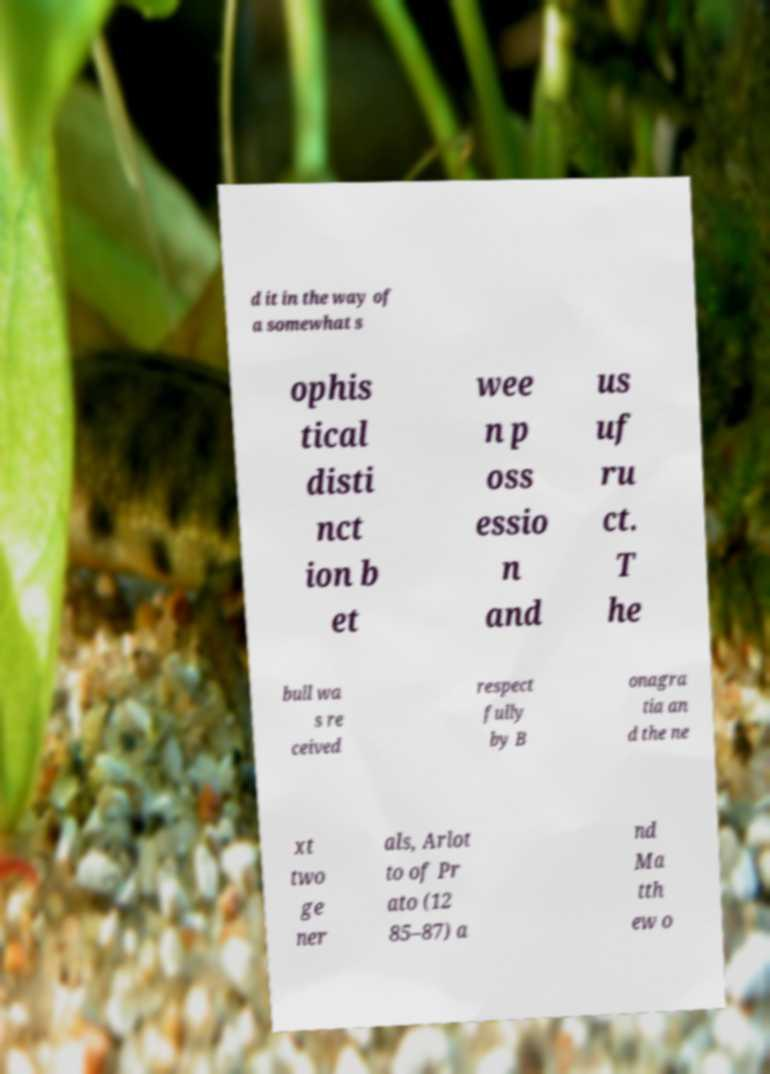Please read and relay the text visible in this image. What does it say? d it in the way of a somewhat s ophis tical disti nct ion b et wee n p oss essio n and us uf ru ct. T he bull wa s re ceived respect fully by B onagra tia an d the ne xt two ge ner als, Arlot to of Pr ato (12 85–87) a nd Ma tth ew o 